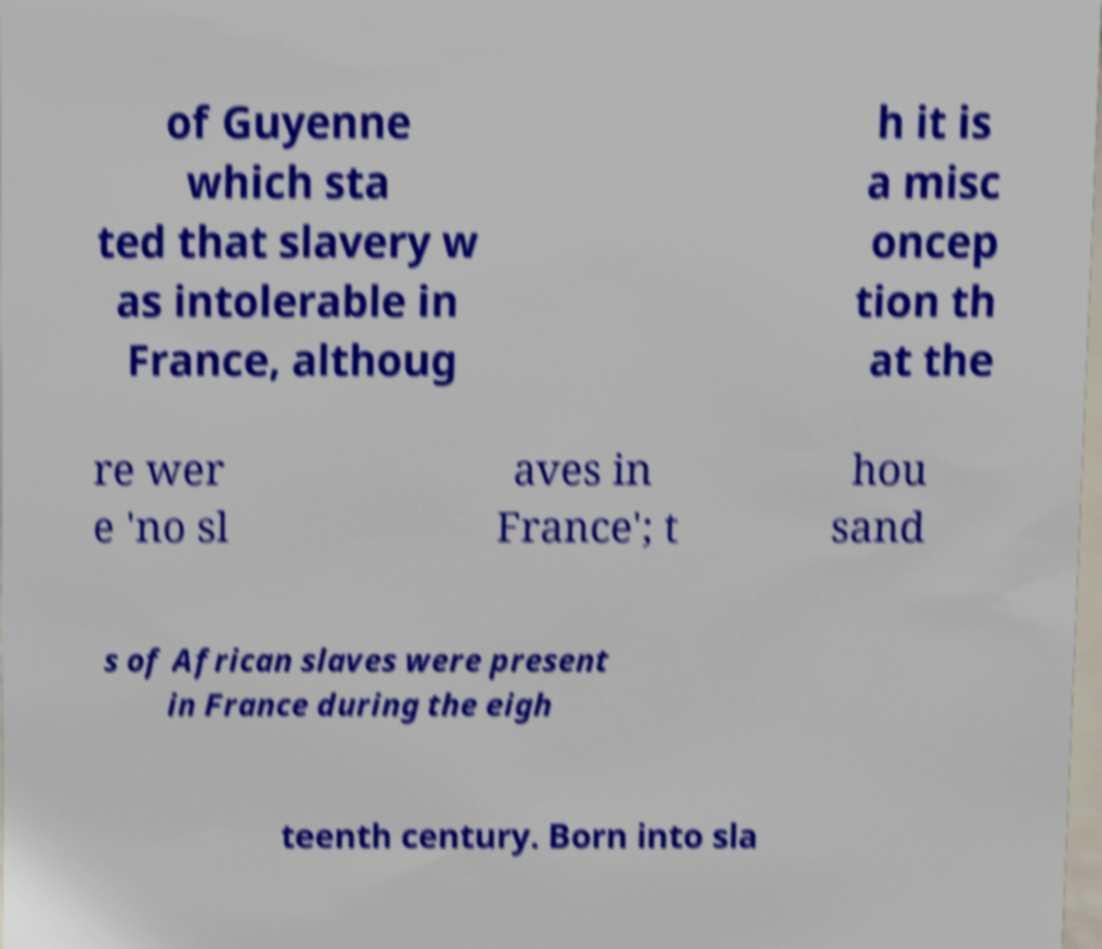Can you read and provide the text displayed in the image?This photo seems to have some interesting text. Can you extract and type it out for me? of Guyenne which sta ted that slavery w as intolerable in France, althoug h it is a misc oncep tion th at the re wer e 'no sl aves in France'; t hou sand s of African slaves were present in France during the eigh teenth century. Born into sla 